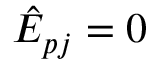Convert formula to latex. <formula><loc_0><loc_0><loc_500><loc_500>\hat { E } _ { p j } = 0</formula> 